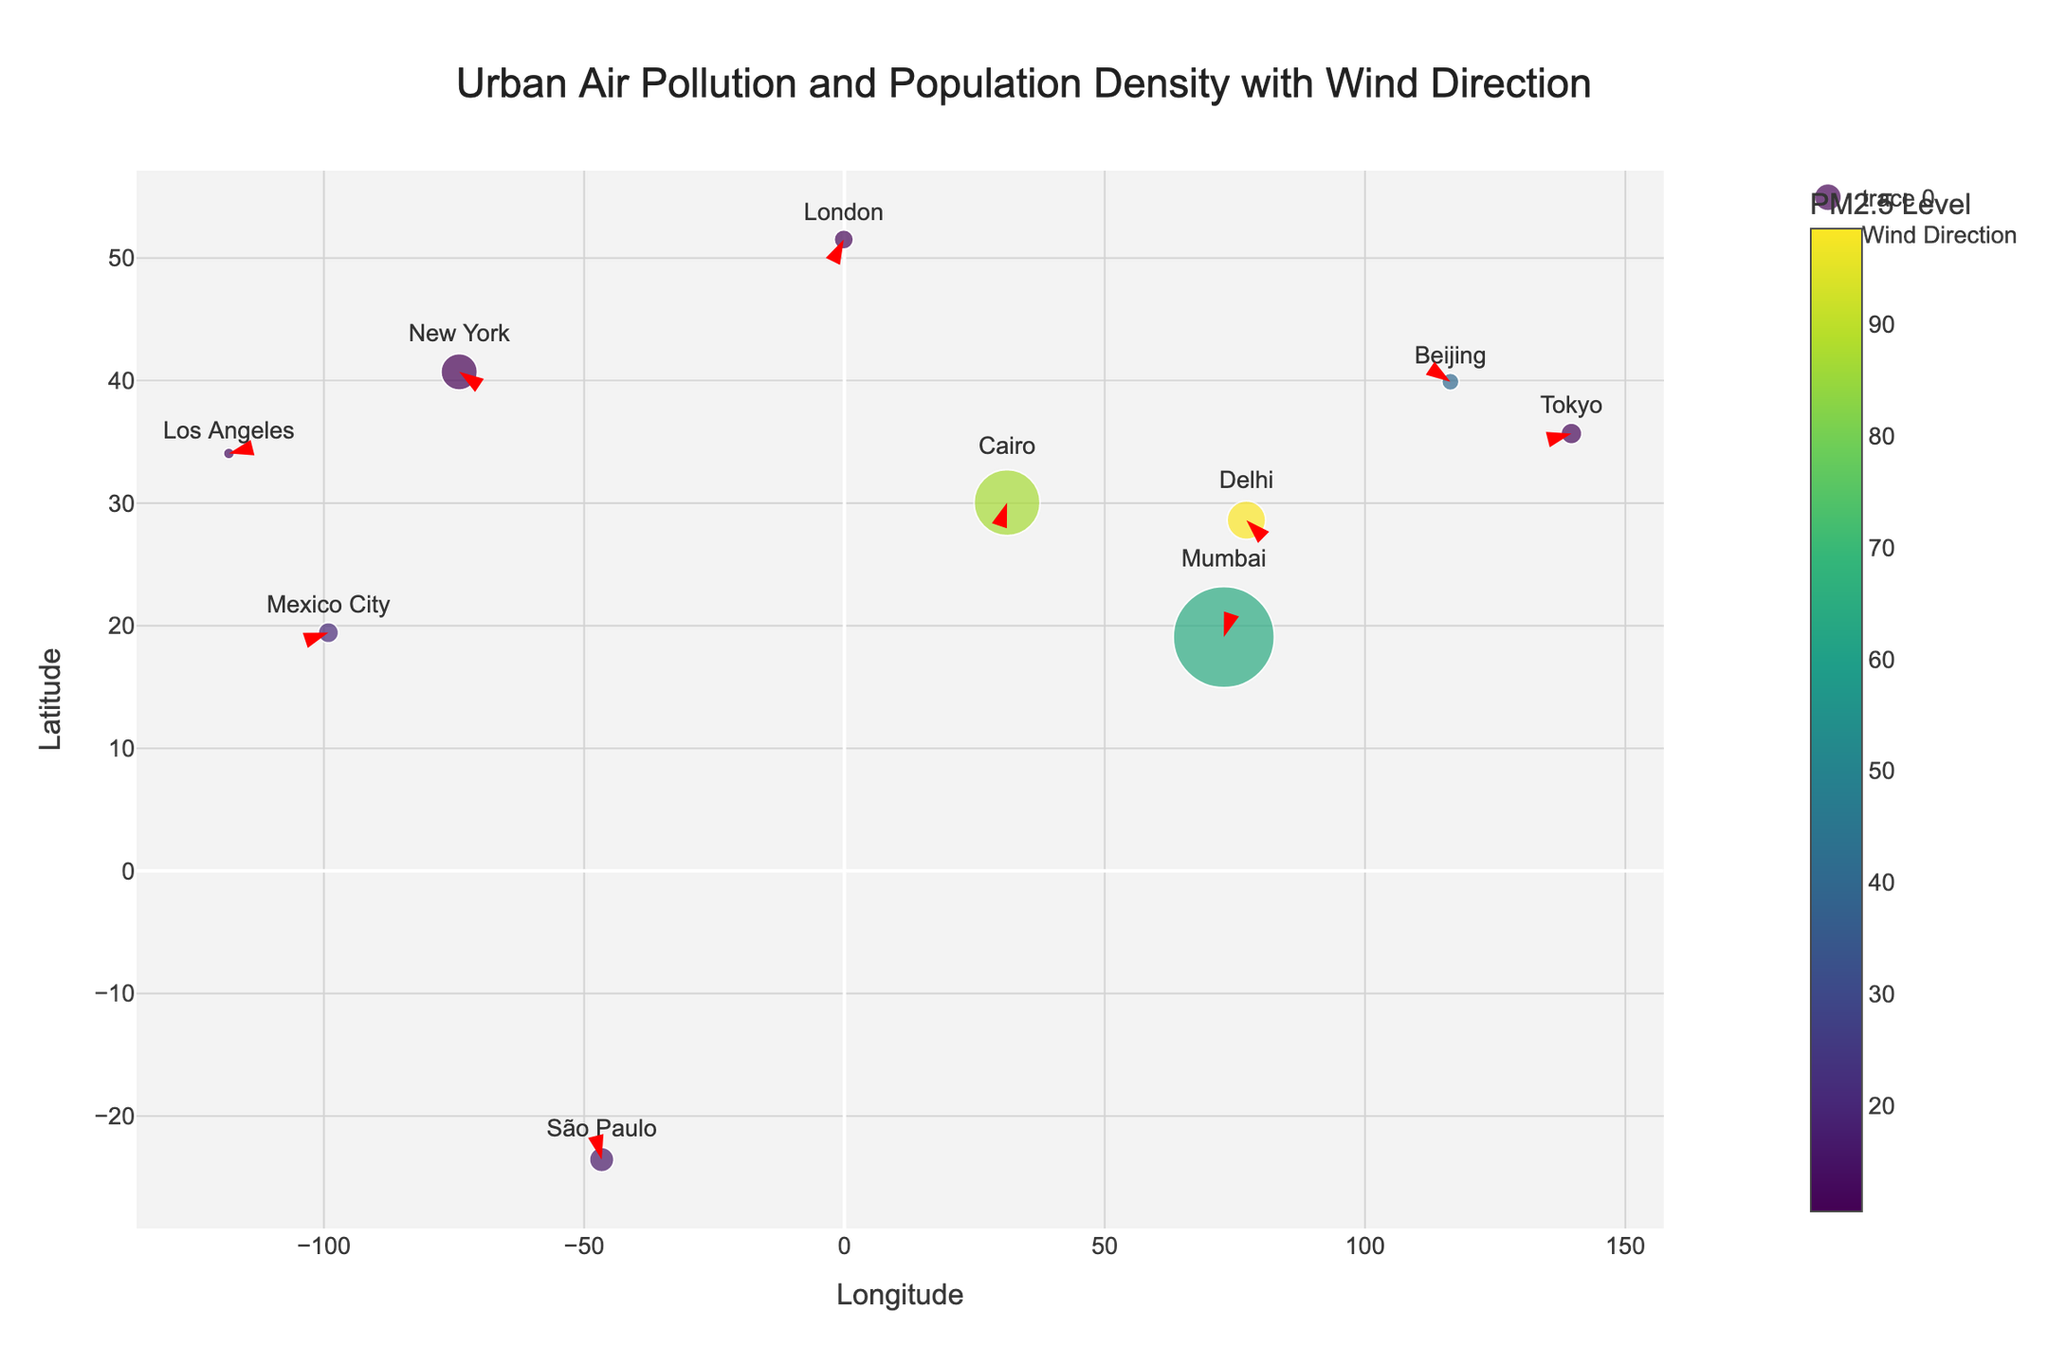What's the title of the plot? Look at the top of the figure, where the title is usually located. The title provides a summary of the main content.
Answer: Urban Air Pollution and Population Density with Wind Direction How many cities are represented in the plot? Count the number of unique city names annotated on the figure. Each marker represents a city.
Answer: 10 Which city has the highest PM2.5 level? Hover over the markers or use the color scale to identify the city with the darkest color, indicating the highest PM2.5 level.
Answer: Delhi What are the coordinates (Longitude, Latitude) of São Paulo? Locate São Paulo on the map and read off the corresponding longitude and latitude values from the axes.
Answer: (-46.6333, -23.5505) Which city has the highest population density? Look for the largest marker on the plot, as marker size corresponds to population density. Verify by hovering to see the population density values.
Answer: Mumbai How does the PM2.5 level in Los Angeles compare to that in New York? Hover over the markers for Los Angeles and New York to retrieve their PM2.5 levels and compare them. Los Angeles has a PM2.5 level of 12.7, while New York has a level of 10.5. Therefore, Los Angeles has a higher PM2.5 level.
Answer: Higher in Los Angeles What is the general direction of the wind in London? Observe the orientation of the arrow (marker) at London's coordinates. The angle and direction of the arrow represent the wind direction.
Answer: Northeast Which city has the lowest population density? Look for the smallest marker on the plot. Verify by hovering over the marker to check the exact population density value.
Answer: Los Angeles Are there any cities where the wind direction is towards the west? Check the angles of the arrows in the markers; an arrow pointing left indicates westward direction.
Answer: São Paulo, Beijing Which city, among Cairo and Mumbai, has a higher PM2.5 level, and by how much? Hover over the markers for Cairo and Mumbai to retrieve their PM2.5 levels. Cairo has a PM2.5 level of 86.9, and Mumbai has a level of 64.1. Subtract Mumbai's level from Cairo's to find the difference.
Answer: Cairo, 22.8 